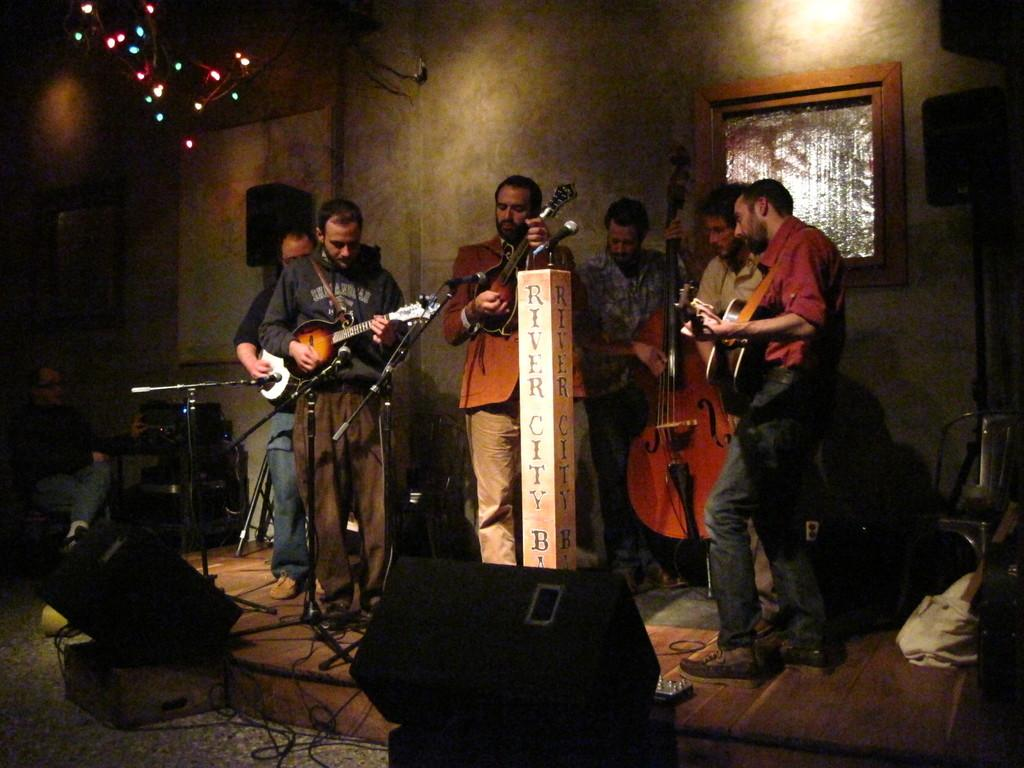What is happening in the image? There is a group of people in the image. Where are the people located? The people are standing on a stage. What are the people doing on the stage? The people are playing musical instruments. Can you see a yak performing with the group of people on the stage? No, there is no yak present in the image. 